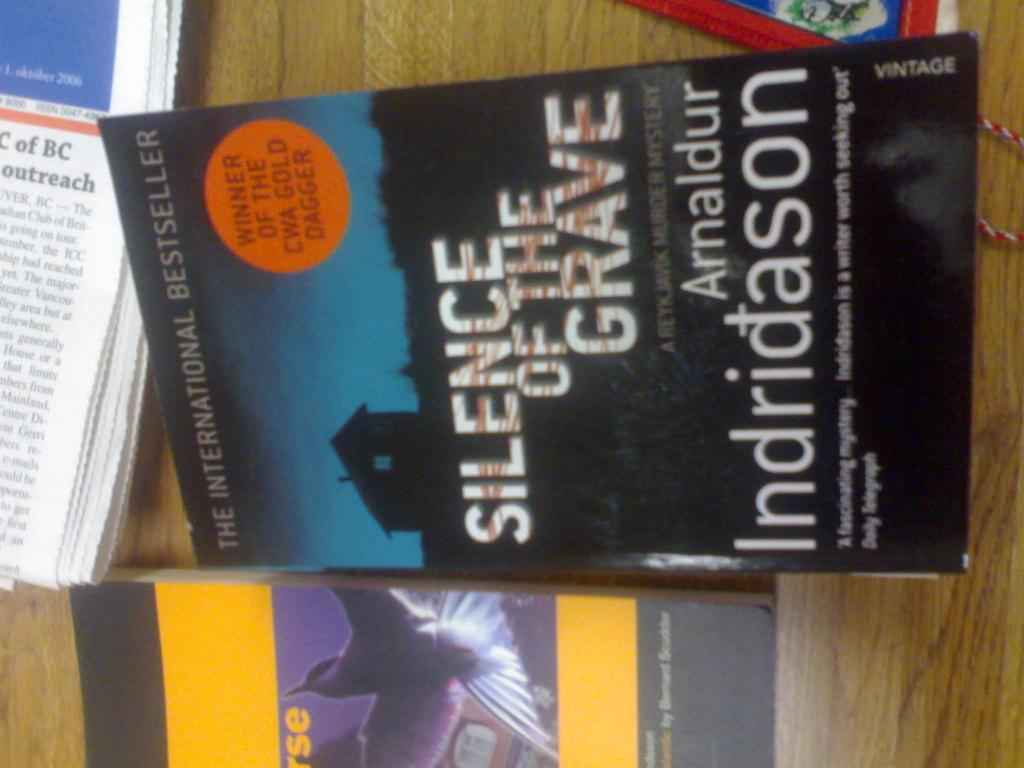<image>
Present a compact description of the photo's key features. The book on the right is titled Silence of the Grave. 